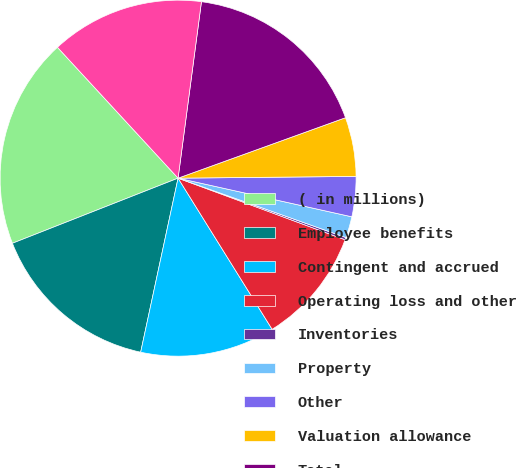Convert chart. <chart><loc_0><loc_0><loc_500><loc_500><pie_chart><fcel>( in millions)<fcel>Employee benefits<fcel>Contingent and accrued<fcel>Operating loss and other<fcel>Inventories<fcel>Property<fcel>Other<fcel>Valuation allowance<fcel>Total<fcel>Intangibles<nl><fcel>19.11%<fcel>15.67%<fcel>12.23%<fcel>10.52%<fcel>0.21%<fcel>1.93%<fcel>3.64%<fcel>5.36%<fcel>17.39%<fcel>13.95%<nl></chart> 